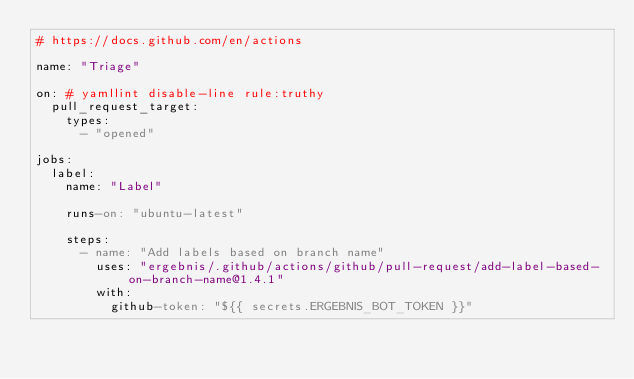<code> <loc_0><loc_0><loc_500><loc_500><_YAML_># https://docs.github.com/en/actions

name: "Triage"

on: # yamllint disable-line rule:truthy
  pull_request_target:
    types:
      - "opened"

jobs:
  label:
    name: "Label"

    runs-on: "ubuntu-latest"

    steps:
      - name: "Add labels based on branch name"
        uses: "ergebnis/.github/actions/github/pull-request/add-label-based-on-branch-name@1.4.1"
        with:
          github-token: "${{ secrets.ERGEBNIS_BOT_TOKEN }}"
</code> 